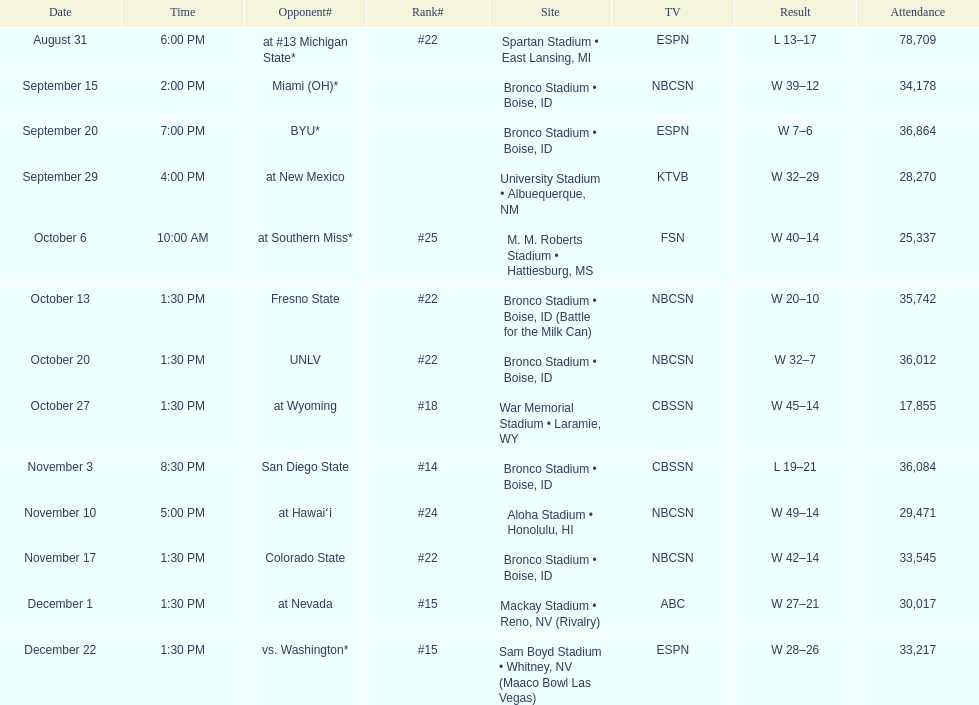Add up the total number of points scored in the last wins for boise state. 146. 